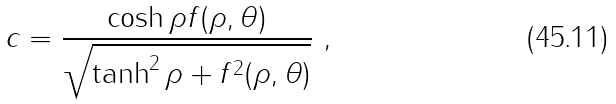<formula> <loc_0><loc_0><loc_500><loc_500>c = \frac { \cosh \rho f ( \rho , \theta ) } { \sqrt { \tanh ^ { 2 } \rho + f ^ { 2 } ( \rho , \theta ) } } \ ,</formula> 